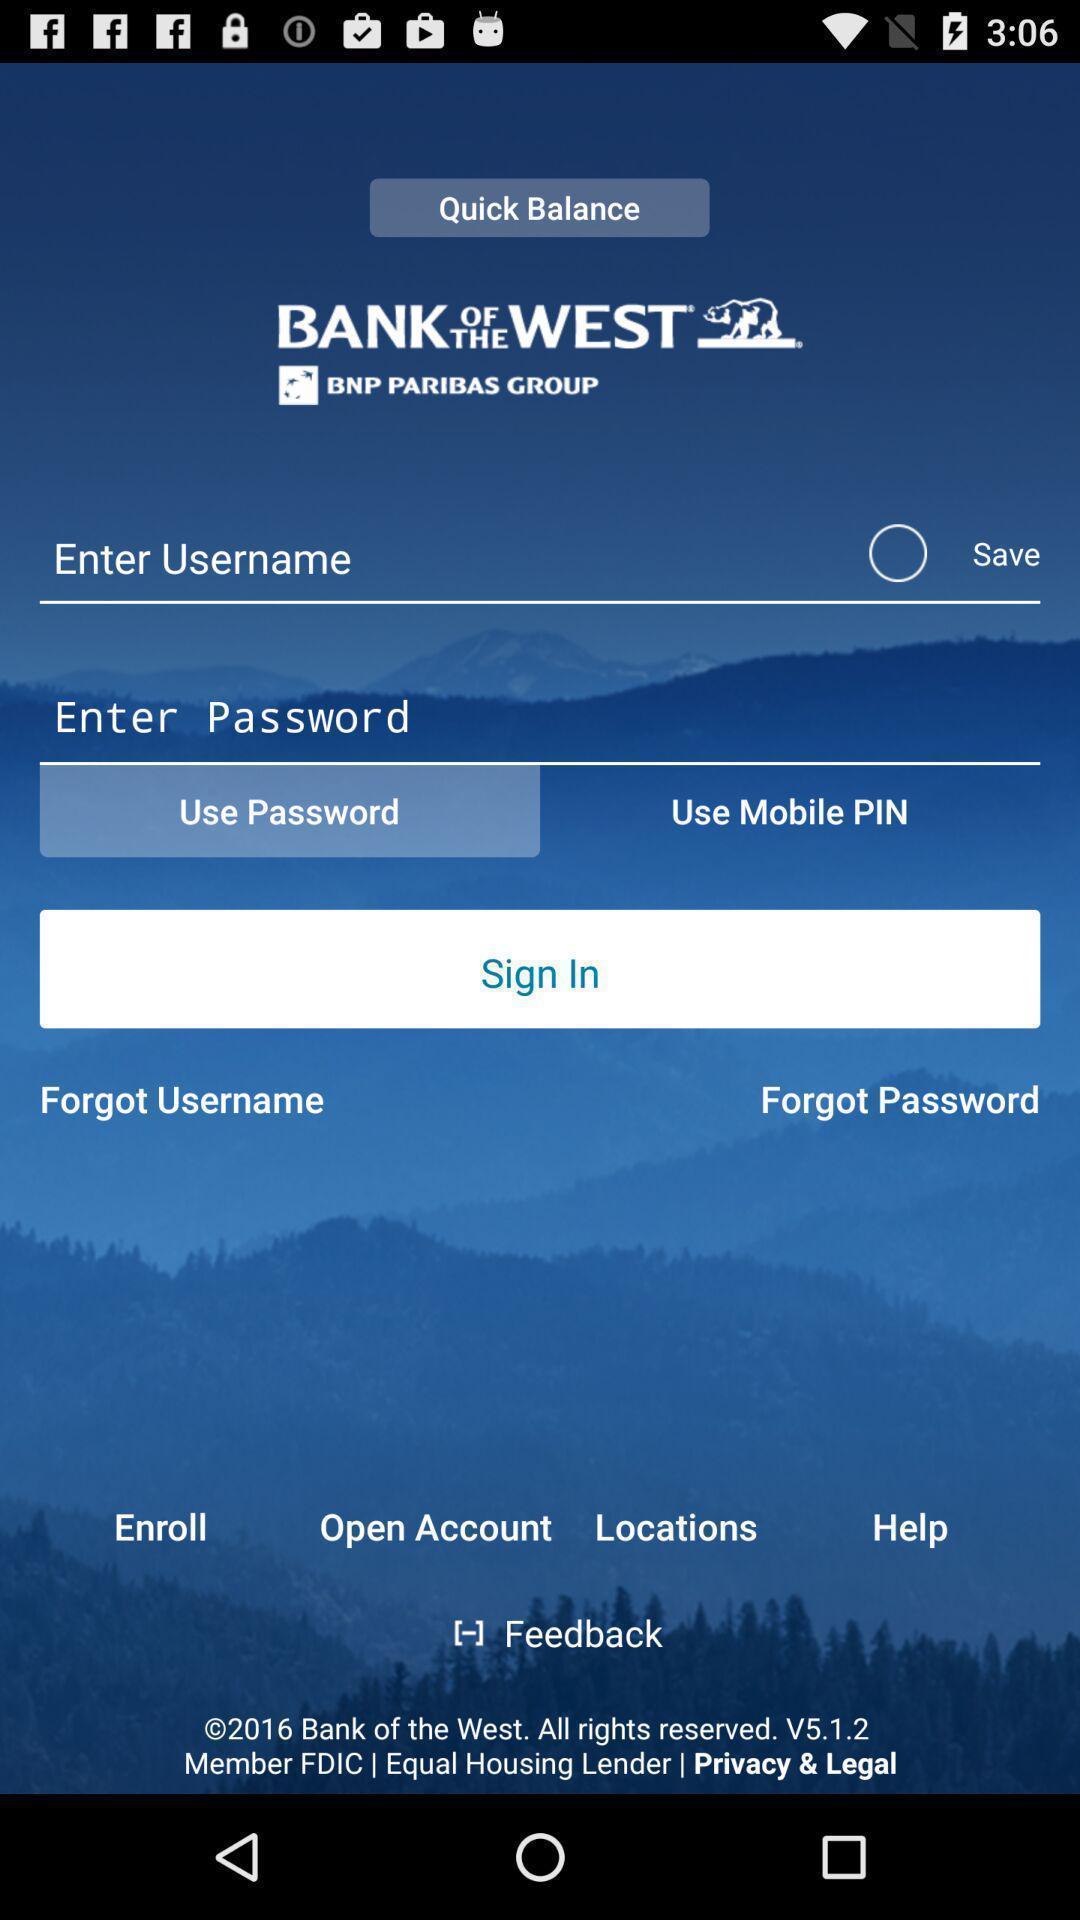Tell me what you see in this picture. Sign in page of a banking app. 